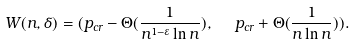<formula> <loc_0><loc_0><loc_500><loc_500>W ( n , \delta ) = ( p _ { c r } - \Theta ( \frac { 1 } { n ^ { 1 - \varepsilon } \ln n } ) , \ \ p _ { c r } + \Theta ( \frac { 1 } { n \ln n } ) ) .</formula> 